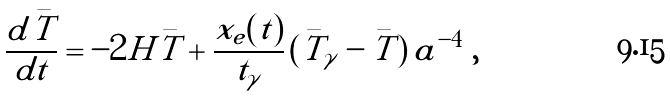Convert formula to latex. <formula><loc_0><loc_0><loc_500><loc_500>\frac { d \bar { T } } { d t } = - 2 H \bar { T } + \frac { x _ { e } ( t ) } { t _ { \gamma } } \, ( \bar { T } _ { \gamma } - \bar { T } ) \, a ^ { - 4 } \ ,</formula> 